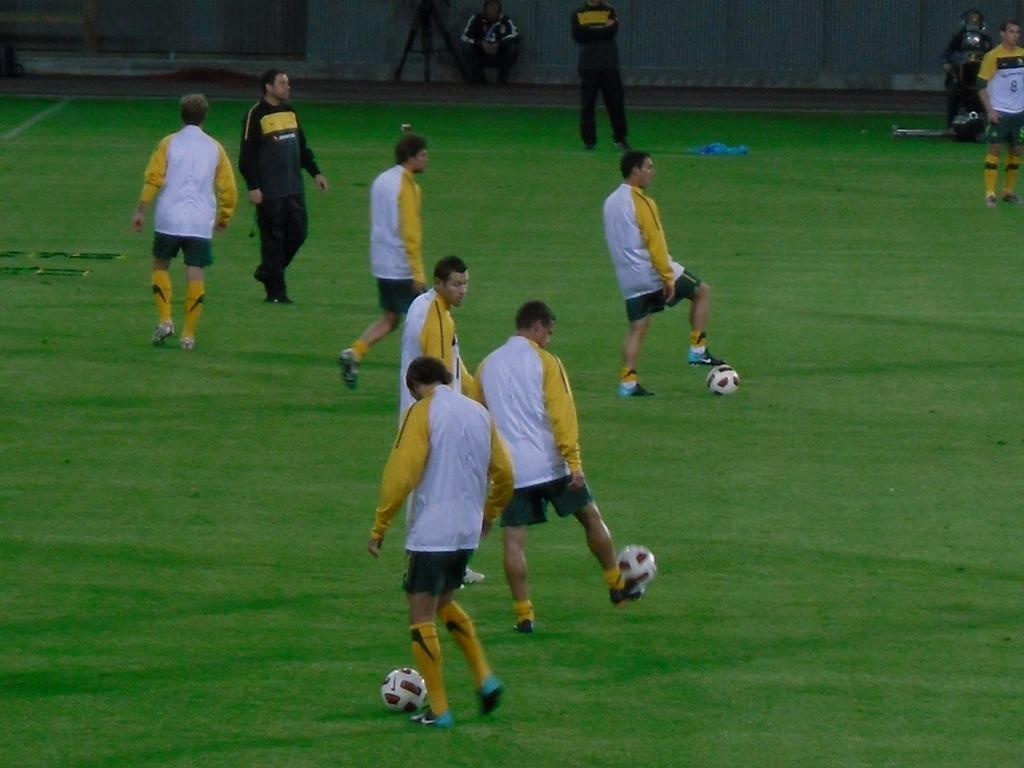What are the players in the image doing? The players in the ground are playing with a ball. What are some of the players doing while playing with the ball? Some of the players are walking. Can you describe the person in the background? In the background, there is a guy standing and watching. What type of paste is being used by the players to stick the ball to the ground? There is no paste present in the image, and the players are not using any substance to stick the ball to the ground. 